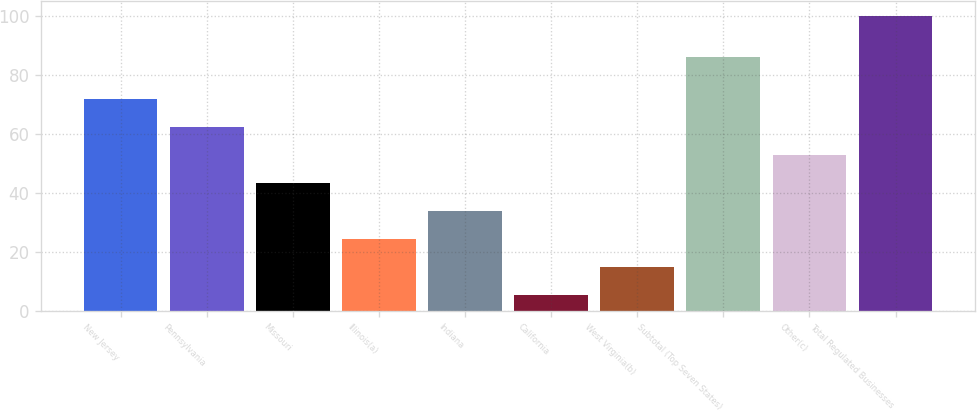Convert chart. <chart><loc_0><loc_0><loc_500><loc_500><bar_chart><fcel>New Jersey<fcel>Pennsylvania<fcel>Missouri<fcel>Illinois(a)<fcel>Indiana<fcel>California<fcel>West Virginia(b)<fcel>Subtotal (Top Seven States)<fcel>Other(c)<fcel>Total Regulated Businesses<nl><fcel>71.59<fcel>62.12<fcel>43.18<fcel>24.24<fcel>33.71<fcel>5.3<fcel>14.77<fcel>86<fcel>52.65<fcel>100<nl></chart> 